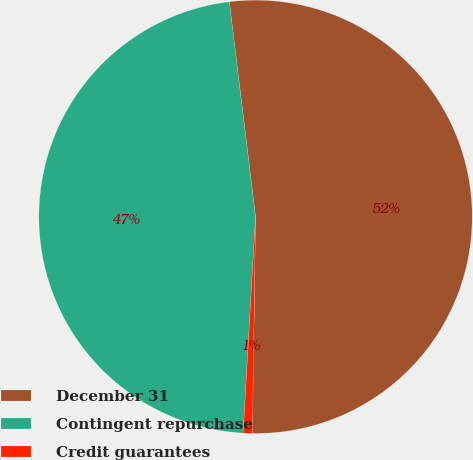<chart> <loc_0><loc_0><loc_500><loc_500><pie_chart><fcel>December 31<fcel>Contingent repurchase<fcel>Credit guarantees<nl><fcel>52.16%<fcel>47.16%<fcel>0.68%<nl></chart> 